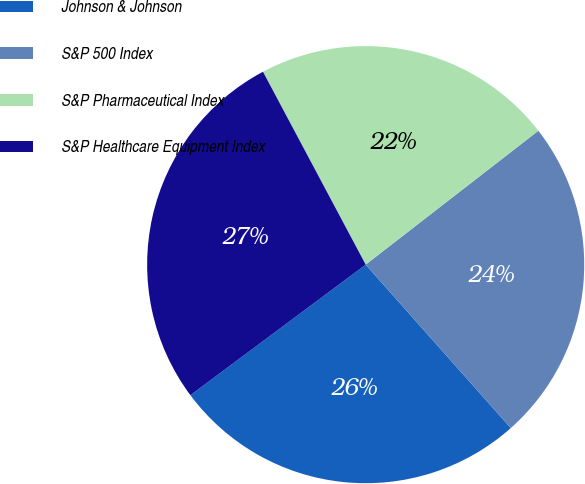<chart> <loc_0><loc_0><loc_500><loc_500><pie_chart><fcel>Johnson & Johnson<fcel>S&P 500 Index<fcel>S&P Pharmaceutical Index<fcel>S&P Healthcare Equipment Index<nl><fcel>26.37%<fcel>23.94%<fcel>22.29%<fcel>27.4%<nl></chart> 